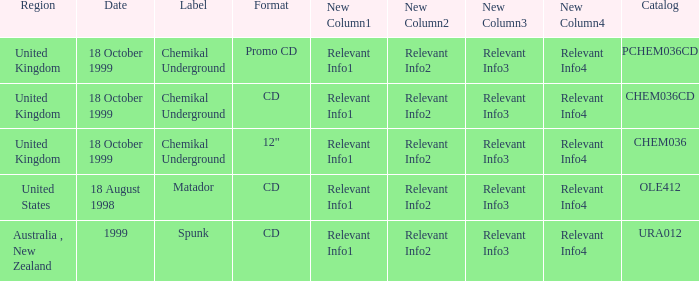What label is associated with the United Kingdom and the chem036 catalog? Chemikal Underground. 